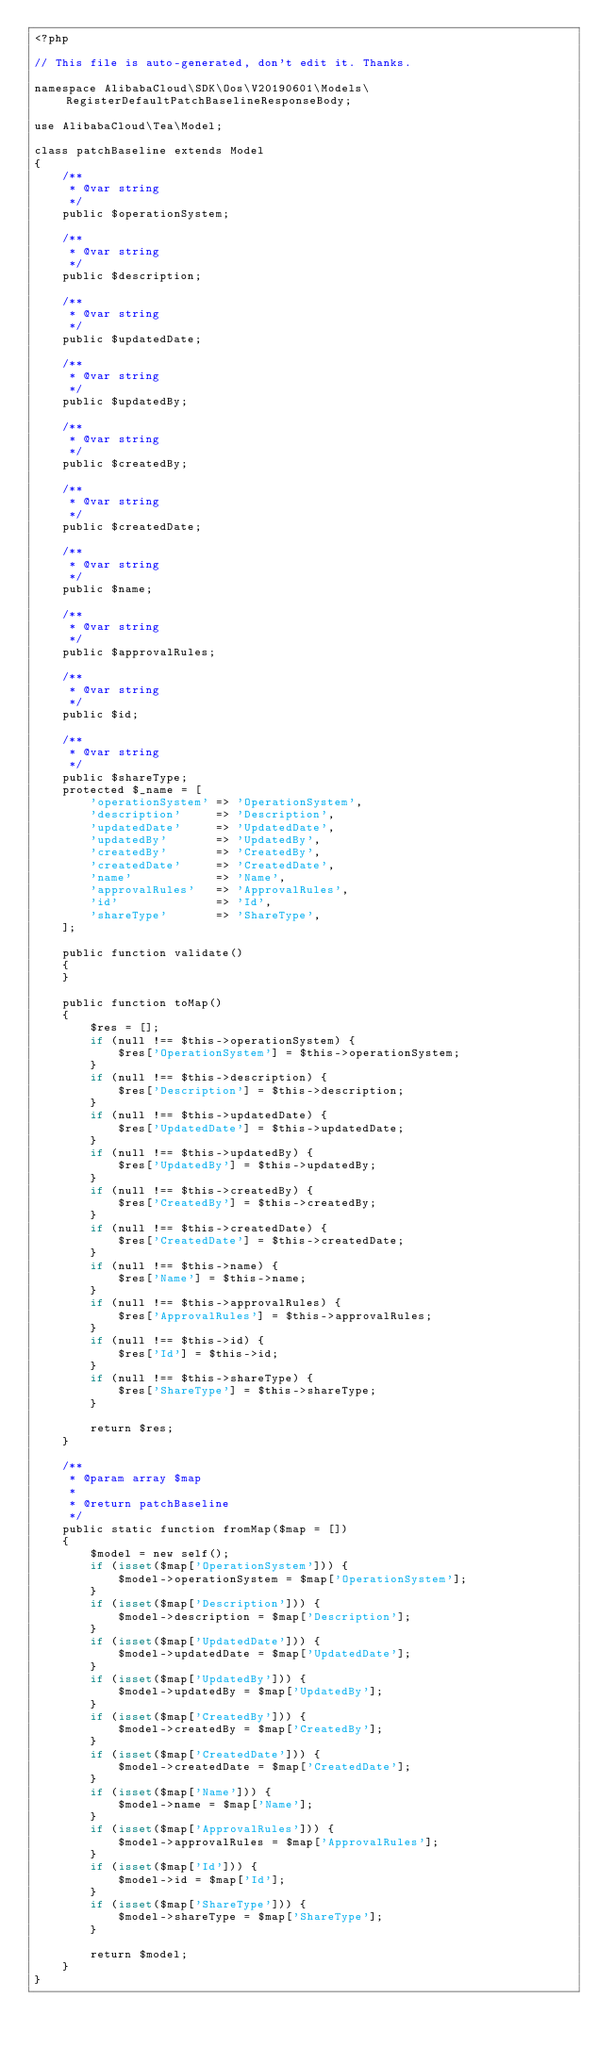<code> <loc_0><loc_0><loc_500><loc_500><_PHP_><?php

// This file is auto-generated, don't edit it. Thanks.

namespace AlibabaCloud\SDK\Oos\V20190601\Models\RegisterDefaultPatchBaselineResponseBody;

use AlibabaCloud\Tea\Model;

class patchBaseline extends Model
{
    /**
     * @var string
     */
    public $operationSystem;

    /**
     * @var string
     */
    public $description;

    /**
     * @var string
     */
    public $updatedDate;

    /**
     * @var string
     */
    public $updatedBy;

    /**
     * @var string
     */
    public $createdBy;

    /**
     * @var string
     */
    public $createdDate;

    /**
     * @var string
     */
    public $name;

    /**
     * @var string
     */
    public $approvalRules;

    /**
     * @var string
     */
    public $id;

    /**
     * @var string
     */
    public $shareType;
    protected $_name = [
        'operationSystem' => 'OperationSystem',
        'description'     => 'Description',
        'updatedDate'     => 'UpdatedDate',
        'updatedBy'       => 'UpdatedBy',
        'createdBy'       => 'CreatedBy',
        'createdDate'     => 'CreatedDate',
        'name'            => 'Name',
        'approvalRules'   => 'ApprovalRules',
        'id'              => 'Id',
        'shareType'       => 'ShareType',
    ];

    public function validate()
    {
    }

    public function toMap()
    {
        $res = [];
        if (null !== $this->operationSystem) {
            $res['OperationSystem'] = $this->operationSystem;
        }
        if (null !== $this->description) {
            $res['Description'] = $this->description;
        }
        if (null !== $this->updatedDate) {
            $res['UpdatedDate'] = $this->updatedDate;
        }
        if (null !== $this->updatedBy) {
            $res['UpdatedBy'] = $this->updatedBy;
        }
        if (null !== $this->createdBy) {
            $res['CreatedBy'] = $this->createdBy;
        }
        if (null !== $this->createdDate) {
            $res['CreatedDate'] = $this->createdDate;
        }
        if (null !== $this->name) {
            $res['Name'] = $this->name;
        }
        if (null !== $this->approvalRules) {
            $res['ApprovalRules'] = $this->approvalRules;
        }
        if (null !== $this->id) {
            $res['Id'] = $this->id;
        }
        if (null !== $this->shareType) {
            $res['ShareType'] = $this->shareType;
        }

        return $res;
    }

    /**
     * @param array $map
     *
     * @return patchBaseline
     */
    public static function fromMap($map = [])
    {
        $model = new self();
        if (isset($map['OperationSystem'])) {
            $model->operationSystem = $map['OperationSystem'];
        }
        if (isset($map['Description'])) {
            $model->description = $map['Description'];
        }
        if (isset($map['UpdatedDate'])) {
            $model->updatedDate = $map['UpdatedDate'];
        }
        if (isset($map['UpdatedBy'])) {
            $model->updatedBy = $map['UpdatedBy'];
        }
        if (isset($map['CreatedBy'])) {
            $model->createdBy = $map['CreatedBy'];
        }
        if (isset($map['CreatedDate'])) {
            $model->createdDate = $map['CreatedDate'];
        }
        if (isset($map['Name'])) {
            $model->name = $map['Name'];
        }
        if (isset($map['ApprovalRules'])) {
            $model->approvalRules = $map['ApprovalRules'];
        }
        if (isset($map['Id'])) {
            $model->id = $map['Id'];
        }
        if (isset($map['ShareType'])) {
            $model->shareType = $map['ShareType'];
        }

        return $model;
    }
}
</code> 